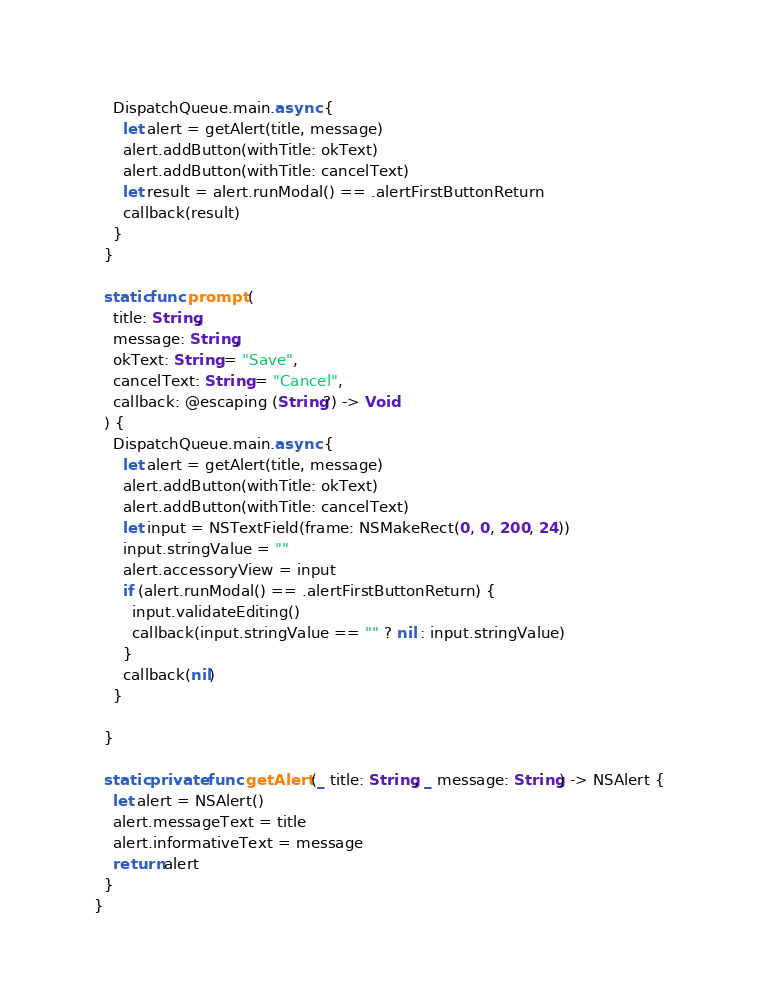Convert code to text. <code><loc_0><loc_0><loc_500><loc_500><_Swift_>    DispatchQueue.main.async {
      let alert = getAlert(title, message)
      alert.addButton(withTitle: okText)
      alert.addButton(withTitle: cancelText)
      let result = alert.runModal() == .alertFirstButtonReturn
      callback(result)
    }
  }
  
  static func prompt (
    title: String,
    message: String,
    okText: String = "Save",
    cancelText: String = "Cancel",
    callback: @escaping (String?) -> Void
  ) {
    DispatchQueue.main.async {
      let alert = getAlert(title, message)
      alert.addButton(withTitle: okText)
      alert.addButton(withTitle: cancelText)
      let input = NSTextField(frame: NSMakeRect(0, 0, 200, 24))
      input.stringValue = ""
      alert.accessoryView = input
      if (alert.runModal() == .alertFirstButtonReturn) {
        input.validateEditing()
        callback(input.stringValue == "" ? nil : input.stringValue)
      }
      callback(nil)
    }
    
  }
  
  static private func getAlert (_ title: String, _ message: String) -> NSAlert {
    let alert = NSAlert()
    alert.messageText = title
    alert.informativeText = message
    return alert
  }
}
</code> 